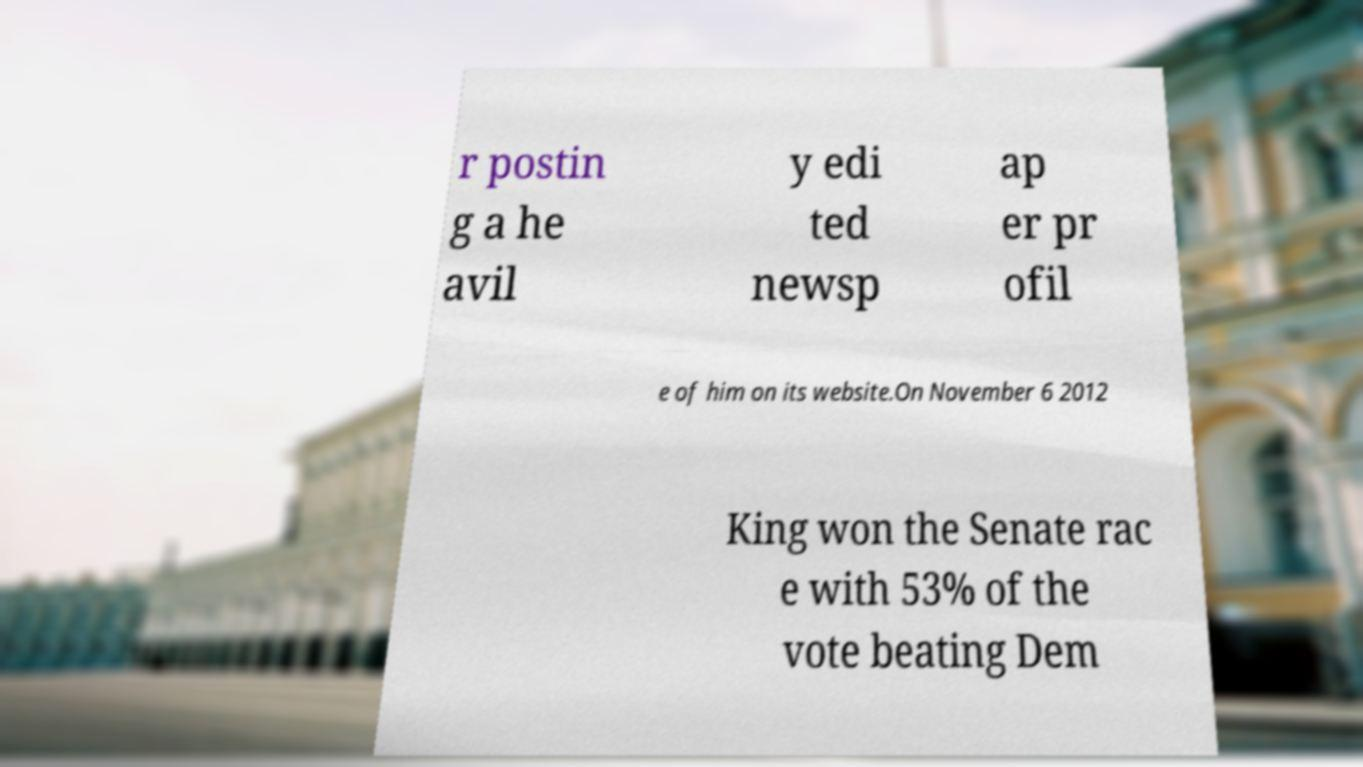Could you assist in decoding the text presented in this image and type it out clearly? r postin g a he avil y edi ted newsp ap er pr ofil e of him on its website.On November 6 2012 King won the Senate rac e with 53% of the vote beating Dem 